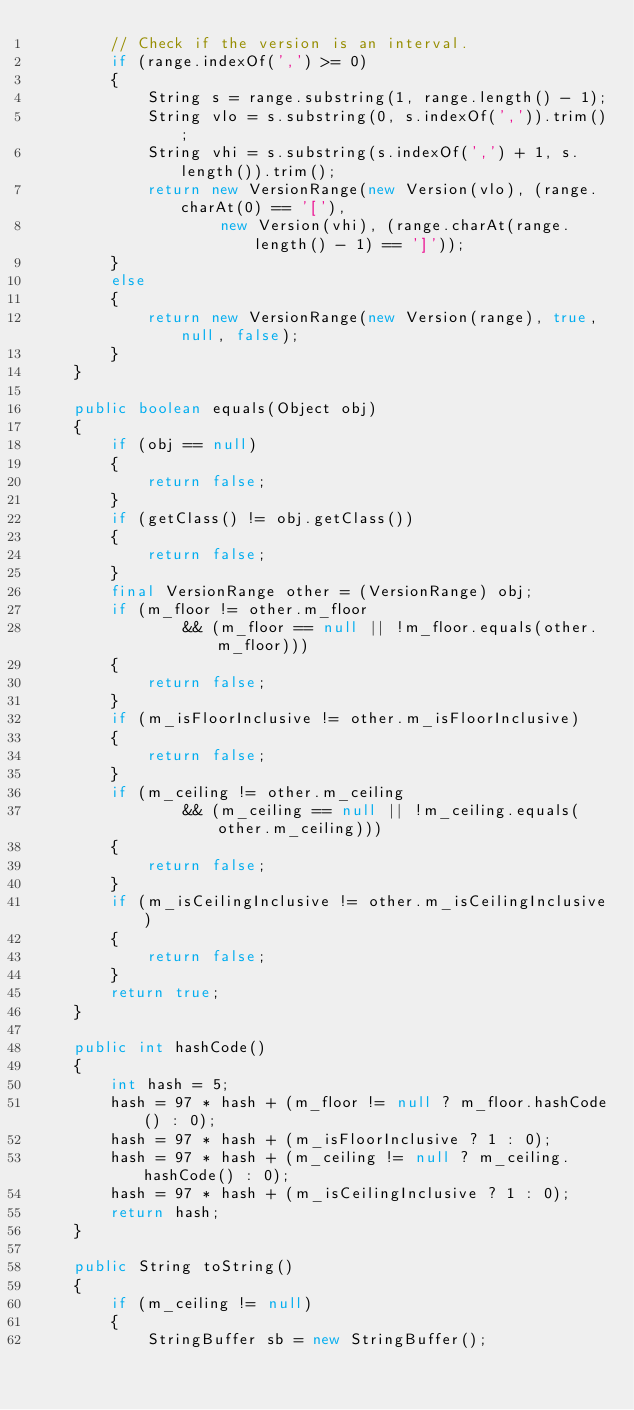Convert code to text. <code><loc_0><loc_0><loc_500><loc_500><_Java_>        // Check if the version is an interval.
        if (range.indexOf(',') >= 0)
        {
            String s = range.substring(1, range.length() - 1);
            String vlo = s.substring(0, s.indexOf(',')).trim();
            String vhi = s.substring(s.indexOf(',') + 1, s.length()).trim();
            return new VersionRange(new Version(vlo), (range.charAt(0) == '['),
                    new Version(vhi), (range.charAt(range.length() - 1) == ']'));
        }
        else
        {
            return new VersionRange(new Version(range), true, null, false);
        }
    }

    public boolean equals(Object obj)
    {
        if (obj == null)
        {
            return false;
        }
        if (getClass() != obj.getClass())
        {
            return false;
        }
        final VersionRange other = (VersionRange) obj;
        if (m_floor != other.m_floor
                && (m_floor == null || !m_floor.equals(other.m_floor)))
        {
            return false;
        }
        if (m_isFloorInclusive != other.m_isFloorInclusive)
        {
            return false;
        }
        if (m_ceiling != other.m_ceiling
                && (m_ceiling == null || !m_ceiling.equals(other.m_ceiling)))
        {
            return false;
        }
        if (m_isCeilingInclusive != other.m_isCeilingInclusive)
        {
            return false;
        }
        return true;
    }

    public int hashCode()
    {
        int hash = 5;
        hash = 97 * hash + (m_floor != null ? m_floor.hashCode() : 0);
        hash = 97 * hash + (m_isFloorInclusive ? 1 : 0);
        hash = 97 * hash + (m_ceiling != null ? m_ceiling.hashCode() : 0);
        hash = 97 * hash + (m_isCeilingInclusive ? 1 : 0);
        return hash;
    }

    public String toString()
    {
        if (m_ceiling != null)
        {
            StringBuffer sb = new StringBuffer();</code> 